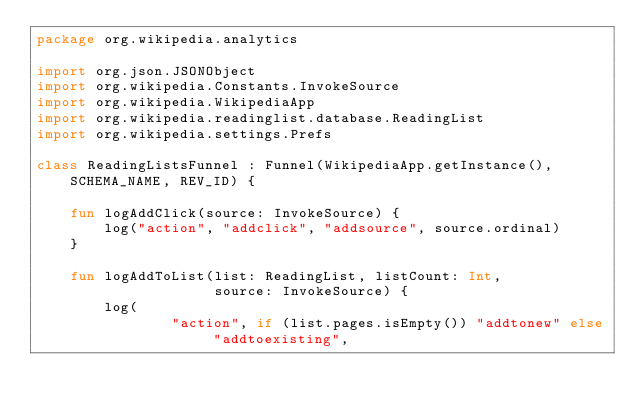Convert code to text. <code><loc_0><loc_0><loc_500><loc_500><_Kotlin_>package org.wikipedia.analytics

import org.json.JSONObject
import org.wikipedia.Constants.InvokeSource
import org.wikipedia.WikipediaApp
import org.wikipedia.readinglist.database.ReadingList
import org.wikipedia.settings.Prefs

class ReadingListsFunnel : Funnel(WikipediaApp.getInstance(), SCHEMA_NAME, REV_ID) {

    fun logAddClick(source: InvokeSource) {
        log("action", "addclick", "addsource", source.ordinal)
    }

    fun logAddToList(list: ReadingList, listCount: Int,
                     source: InvokeSource) {
        log(
                "action", if (list.pages.isEmpty()) "addtonew" else "addtoexisting",</code> 